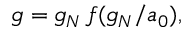Convert formula to latex. <formula><loc_0><loc_0><loc_500><loc_500>g = g _ { N } \, f ( g _ { N } / a _ { 0 } ) ,</formula> 